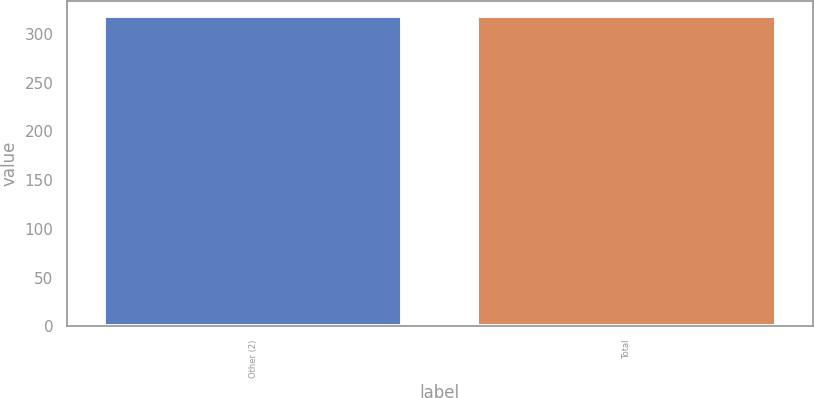Convert chart. <chart><loc_0><loc_0><loc_500><loc_500><bar_chart><fcel>Other (2)<fcel>Total<nl><fcel>318<fcel>318.1<nl></chart> 